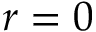<formula> <loc_0><loc_0><loc_500><loc_500>r = 0</formula> 